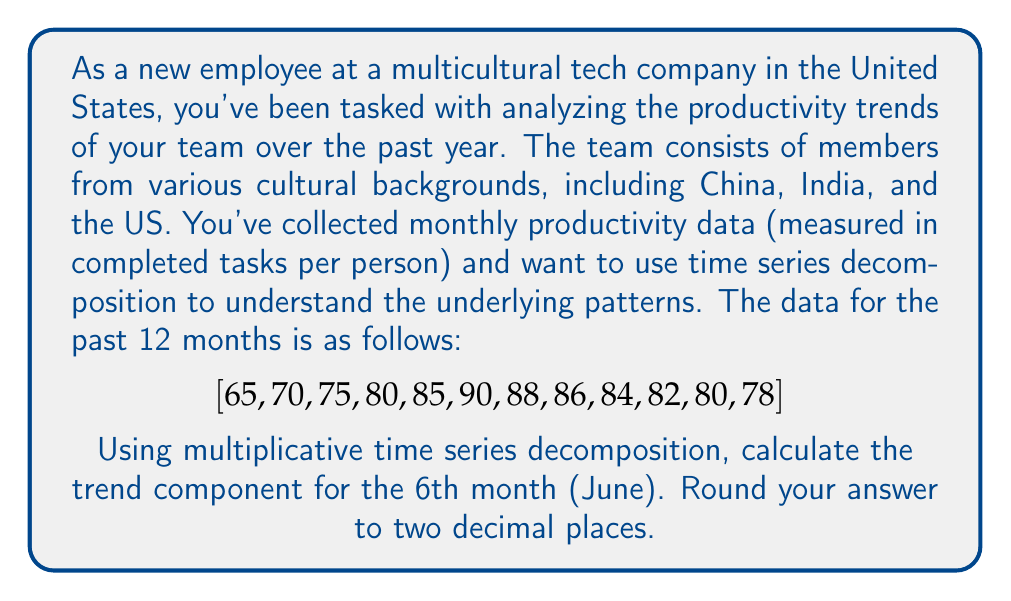Can you answer this question? To solve this problem, we'll use multiplicative time series decomposition. The steps are as follows:

1) First, we need to calculate the centered moving average (CMA) to estimate the trend-cycle component. For monthly data, we use a 12-month moving average, then center it.

2) Calculate the 12-month moving average:
   $$MA_{12} = \frac{65 + 70 + ... + 80 + 78}{12} = 80.25$$
   $$MA_{12} = \frac{70 + 75 + ... + 78 + 77}{12} = 81.25$$ (assuming next month is 77)

3) Center the moving average:
   $$CMA_6 = \frac{80.25 + 81.25}{2} = 80.75$$

4) In multiplicative decomposition, we assume:
   $$Y_t = T_t \times S_t \times I_t$$
   Where $Y_t$ is the observed value, $T_t$ is the trend component, $S_t$ is the seasonal component, and $I_t$ is the irregular component.

5) To estimate the seasonal-irregular component, divide the observed value by the CMA:
   $$\frac{Y_t}{CMA_t} = S_t \times I_t$$
   $$\frac{90}{80.75} \approx 1.1146$$

6) To get the final trend component, we divide the observed value by the estimated seasonal-irregular component:
   $$T_t = \frac{Y_t}{S_t \times I_t} = \frac{90}{1.1146} \approx 80.75$$

Therefore, the trend component for the 6th month (June) is approximately 80.75.
Answer: 80.75 